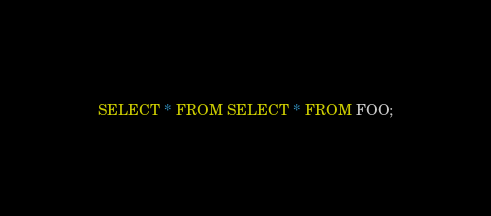<code> <loc_0><loc_0><loc_500><loc_500><_SQL_>SELECT * FROM SELECT * FROM FOO;</code> 